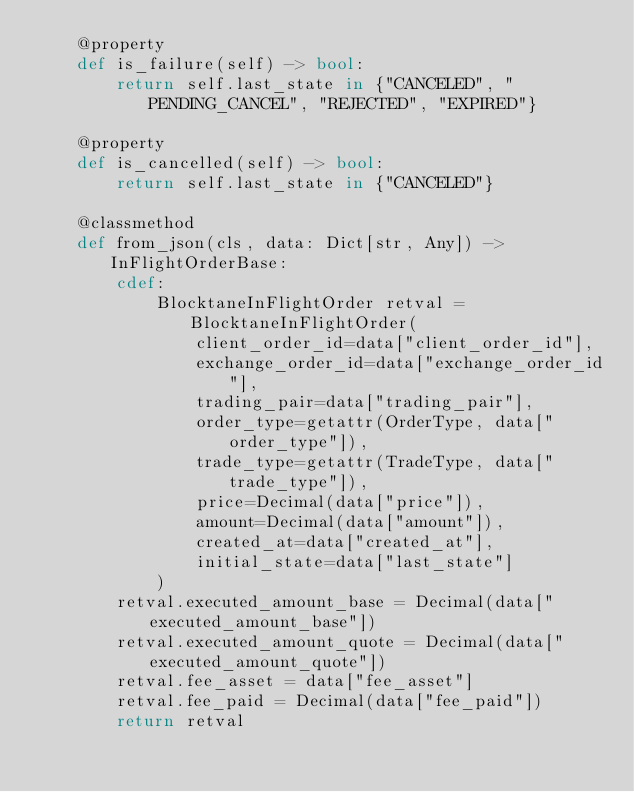<code> <loc_0><loc_0><loc_500><loc_500><_Cython_>    @property
    def is_failure(self) -> bool:
        return self.last_state in {"CANCELED", "PENDING_CANCEL", "REJECTED", "EXPIRED"}

    @property
    def is_cancelled(self) -> bool:
        return self.last_state in {"CANCELED"}

    @classmethod
    def from_json(cls, data: Dict[str, Any]) -> InFlightOrderBase:
        cdef:
            BlocktaneInFlightOrder retval = BlocktaneInFlightOrder(
                client_order_id=data["client_order_id"],
                exchange_order_id=data["exchange_order_id"],
                trading_pair=data["trading_pair"],
                order_type=getattr(OrderType, data["order_type"]),
                trade_type=getattr(TradeType, data["trade_type"]),
                price=Decimal(data["price"]),
                amount=Decimal(data["amount"]),
                created_at=data["created_at"],
                initial_state=data["last_state"]
            )
        retval.executed_amount_base = Decimal(data["executed_amount_base"])
        retval.executed_amount_quote = Decimal(data["executed_amount_quote"])
        retval.fee_asset = data["fee_asset"]
        retval.fee_paid = Decimal(data["fee_paid"])
        return retval
</code> 